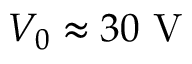<formula> <loc_0><loc_0><loc_500><loc_500>V _ { 0 } \approx 3 0 V</formula> 